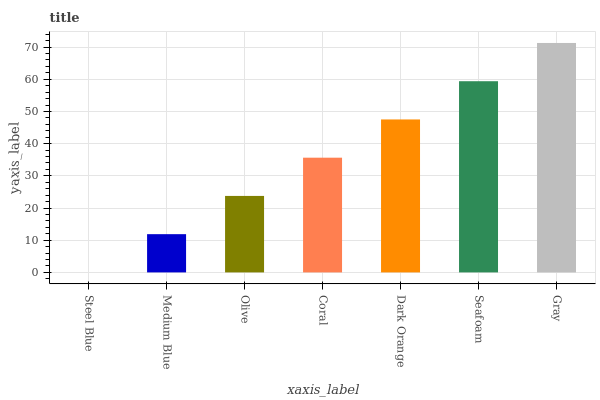Is Steel Blue the minimum?
Answer yes or no. Yes. Is Gray the maximum?
Answer yes or no. Yes. Is Medium Blue the minimum?
Answer yes or no. No. Is Medium Blue the maximum?
Answer yes or no. No. Is Medium Blue greater than Steel Blue?
Answer yes or no. Yes. Is Steel Blue less than Medium Blue?
Answer yes or no. Yes. Is Steel Blue greater than Medium Blue?
Answer yes or no. No. Is Medium Blue less than Steel Blue?
Answer yes or no. No. Is Coral the high median?
Answer yes or no. Yes. Is Coral the low median?
Answer yes or no. Yes. Is Olive the high median?
Answer yes or no. No. Is Seafoam the low median?
Answer yes or no. No. 